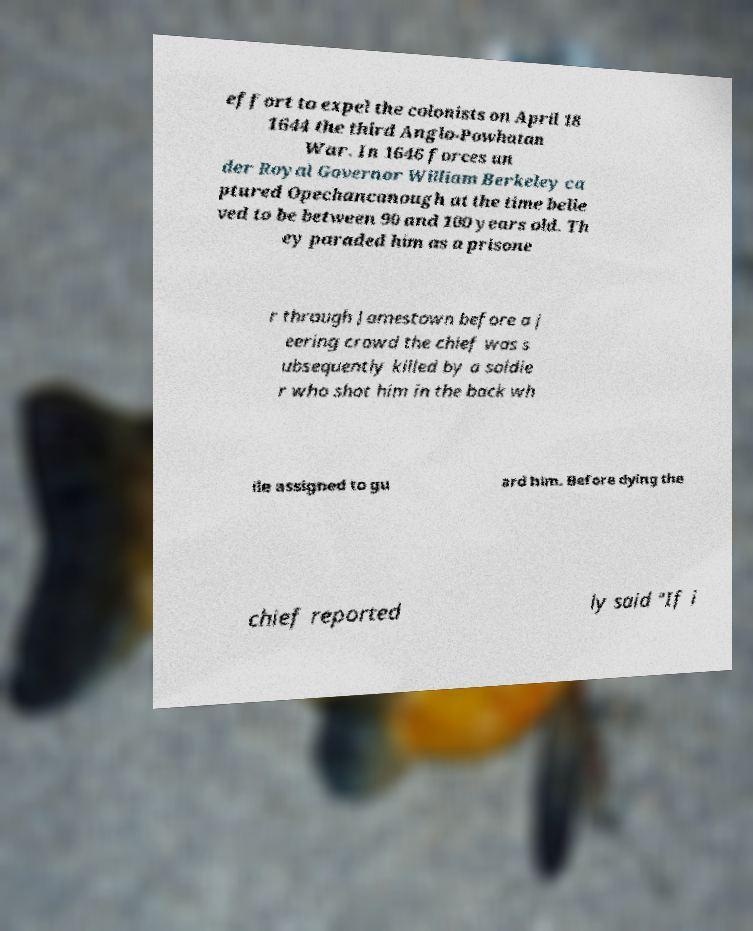Please identify and transcribe the text found in this image. effort to expel the colonists on April 18 1644 the third Anglo-Powhatan War. In 1646 forces un der Royal Governor William Berkeley ca ptured Opechancanough at the time belie ved to be between 90 and 100 years old. Th ey paraded him as a prisone r through Jamestown before a j eering crowd the chief was s ubsequently killed by a soldie r who shot him in the back wh ile assigned to gu ard him. Before dying the chief reported ly said "If i 